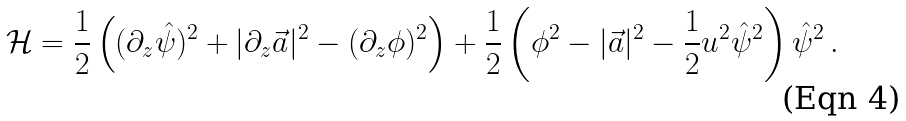<formula> <loc_0><loc_0><loc_500><loc_500>\mathcal { H } = \frac { 1 } { 2 } \left ( ( \partial _ { z } \hat { \psi } ) ^ { 2 } + | \partial _ { z } \vec { a } | ^ { 2 } - ( \partial _ { z } \phi ) ^ { 2 } \right ) + \frac { 1 } { 2 } \left ( \phi ^ { 2 } - | \vec { a } | ^ { 2 } - \frac { 1 } { 2 } u ^ { 2 } \hat { \psi } ^ { 2 } \right ) \hat { \psi } ^ { 2 } \, .</formula> 